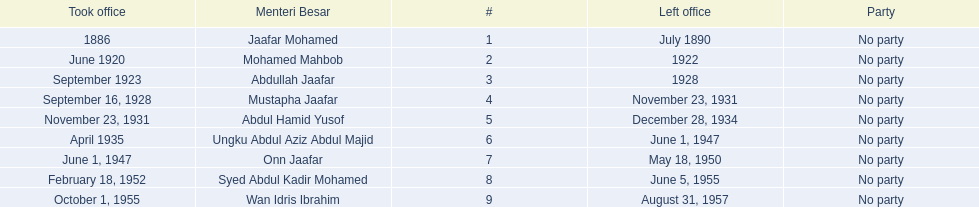Who was in office previous to abdullah jaafar? Mohamed Mahbob. Parse the table in full. {'header': ['Took office', 'Menteri Besar', '#', 'Left office', 'Party'], 'rows': [['1886', 'Jaafar Mohamed', '1', 'July 1890', 'No party'], ['June 1920', 'Mohamed Mahbob', '2', '1922', 'No party'], ['September 1923', 'Abdullah Jaafar', '3', '1928', 'No party'], ['September 16, 1928', 'Mustapha Jaafar', '4', 'November 23, 1931', 'No party'], ['November 23, 1931', 'Abdul Hamid Yusof', '5', 'December 28, 1934', 'No party'], ['April 1935', 'Ungku Abdul Aziz Abdul Majid', '6', 'June 1, 1947', 'No party'], ['June 1, 1947', 'Onn Jaafar', '7', 'May 18, 1950', 'No party'], ['February 18, 1952', 'Syed Abdul Kadir Mohamed', '8', 'June 5, 1955', 'No party'], ['October 1, 1955', 'Wan Idris Ibrahim', '9', 'August 31, 1957', 'No party']]} 